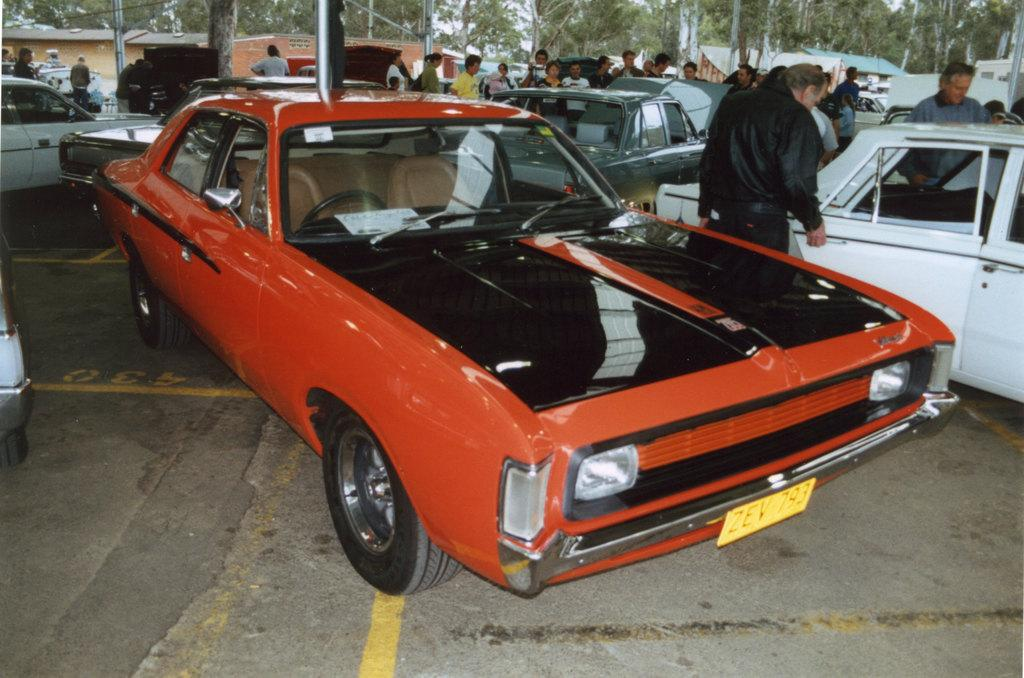What can be seen on the path in the image? There are vehicles on the path in the image. What is visible in the background of the image? There are people, houses, and trees in the background of the image. What type of reaction can be seen from the brick in the image? There is no brick present in the image, and therefore no reaction can be observed. 